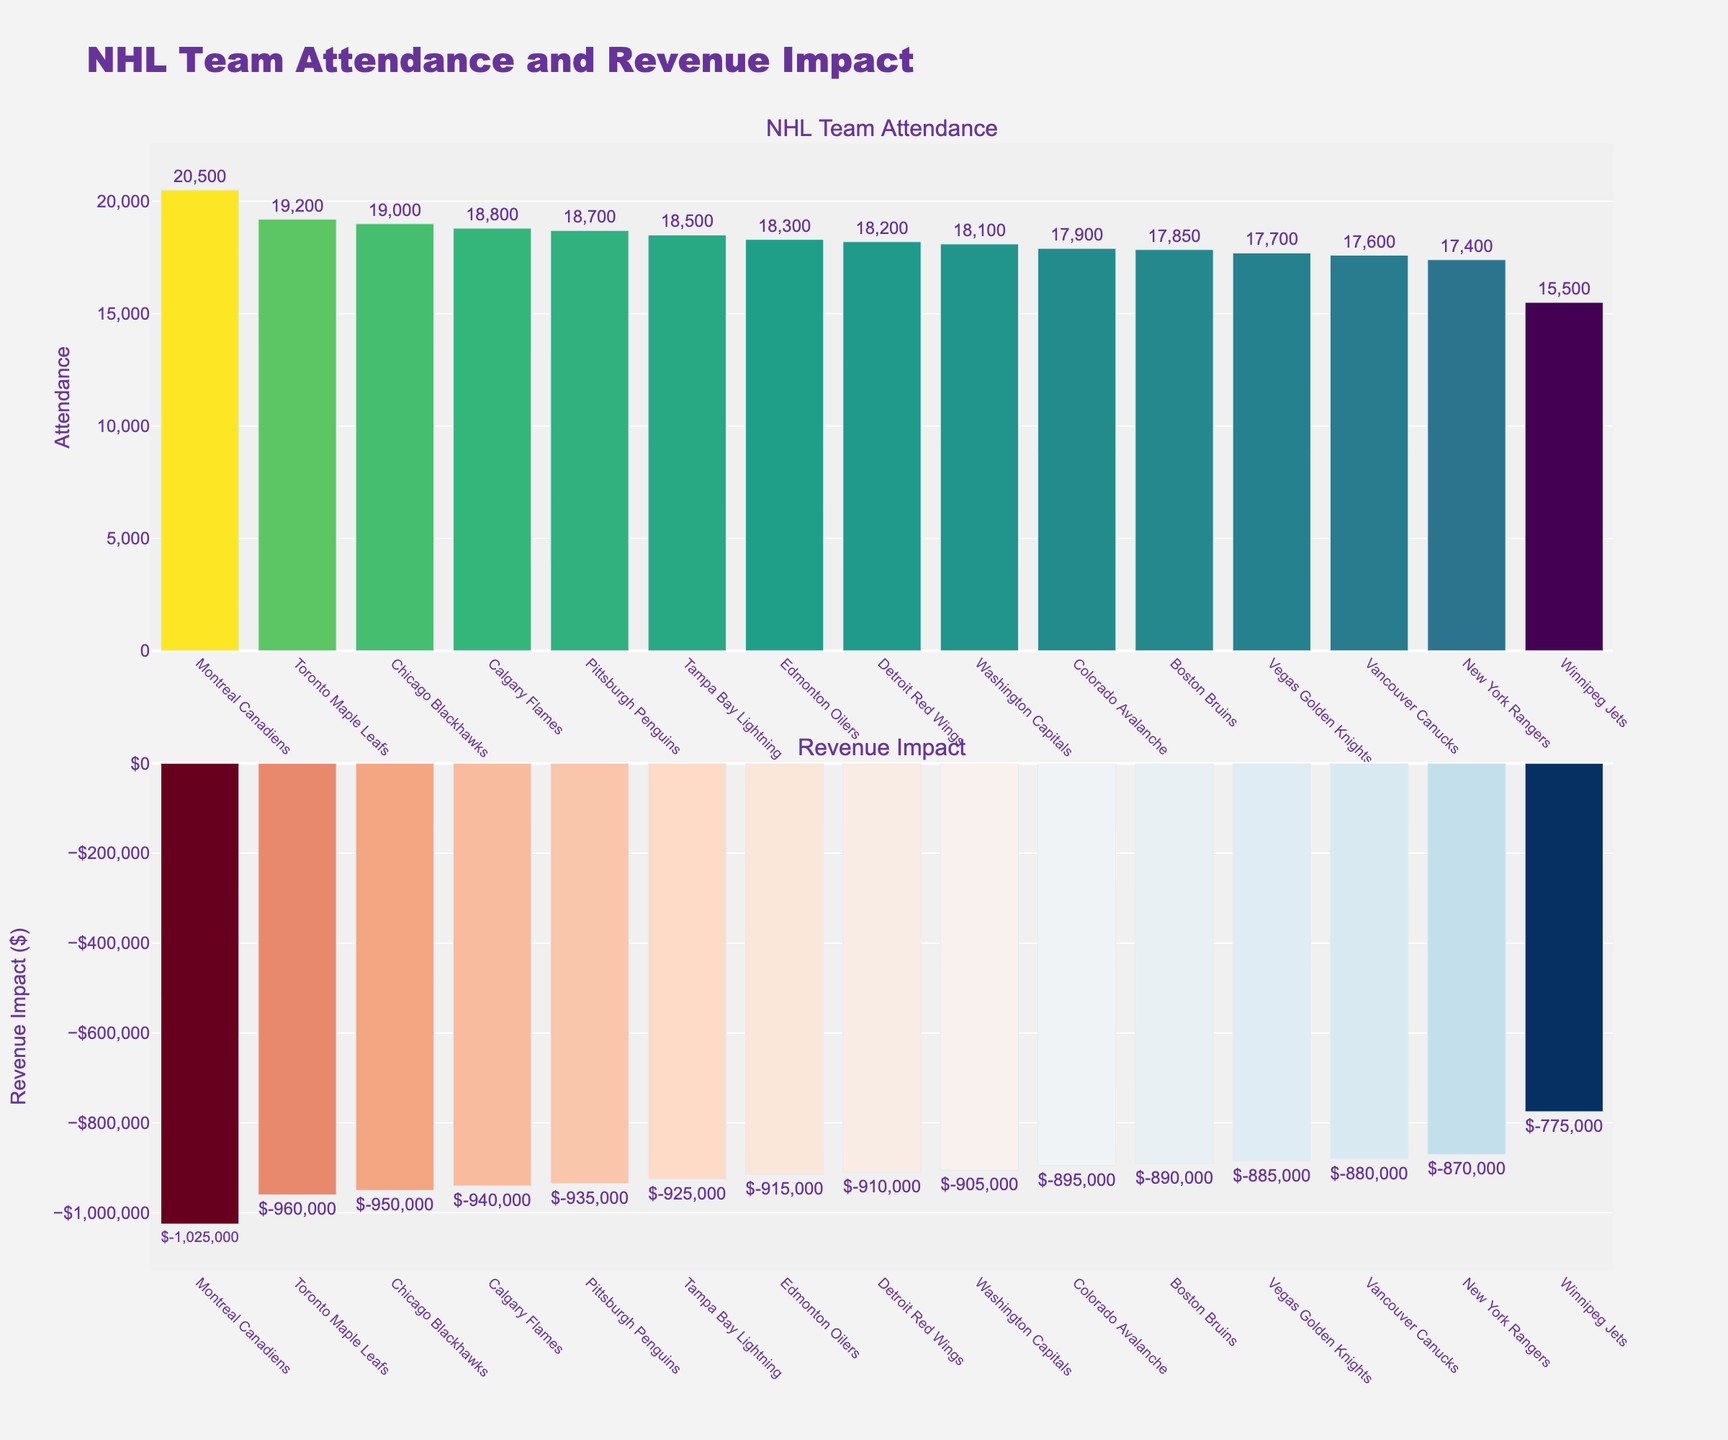How many teams have an attendance higher than 18,000? Count the number of teams whose attendance values exceed 18,000 from the attendance bar chart.
Answer: 10 Which team has the highest attendance and what is the value? Identify the highest bar in the "NHL Team Attendance" subplot and read the corresponding team's name and attendance value.
Answer: Montreal Canadiens, 20,500 What is the range of attendance values in the chart? Subtract the smallest attendance value from the largest. The largest attendance is 20,500 (Montreal Canadiens) and the smallest is 15,500 (Winnipeg Jets). The range is 20,500 - 15,500.
Answer: 5,000 Which team has the least negative revenue impact? Identify the bar closest to zero (least negative) in the "Revenue Impact" subplot by looking for the highest value in the negative range.
Answer: Winnipeg Jets, -775,000 Compare the attendance between the Calgary Flames and the New York Rangers. Find both teams on the "NHL Team Attendance" subplot, then compare their attendance values. Calgary Flames have 18,800 and New York Rangers have 17,400. Calgary Flames have higher attendance.
Answer: Calgary Flames have higher attendance What is the average attendance of the teams? Sum all the attendance values and divide by the number of teams (15). Total attendance is 276,750. 276,750 / 15 equals 18,450.
Answer: 18,450 Which team has the largest negative revenue impact and what is that value? Identify the bar representing the lowest (most negative) value in the "Revenue Impact" subplot.
Answer: Montreal Canadiens, -1,025,000 What is the difference in attendance between the highest and lowest attended teams? Subtract the attendance of the team with the lowest attendance (Winnipeg Jets, 15,500) from the team with the highest attendance (Montreal Canadiens, 20,500).
Answer: 5,000 How does the attendance of the Chicago Blackhawks compare to that of the Toronto Maple Leafs? Look at the "NHL Team Attendance" subplot and find both teams. Chicago Blackhawks have 19,000 and Toronto Maple Leafs have 19,200. Toronto Maple Leafs have slightly higher attendance.
Answer: Toronto Maple Leafs have higher attendance Which teams have an attendance value within 500 of 18,000? Look for teams with attendance values ranging from 17,500 to 18,500. These teams are Boston Bruins (17,850), Washington Capitals (18,100), Detroit Red Wings (18,200), and Colorado Avalanche (17,900).
Answer: Boston Bruins, Washington Capitals, Detroit Red Wings, Colorado Avalanche 